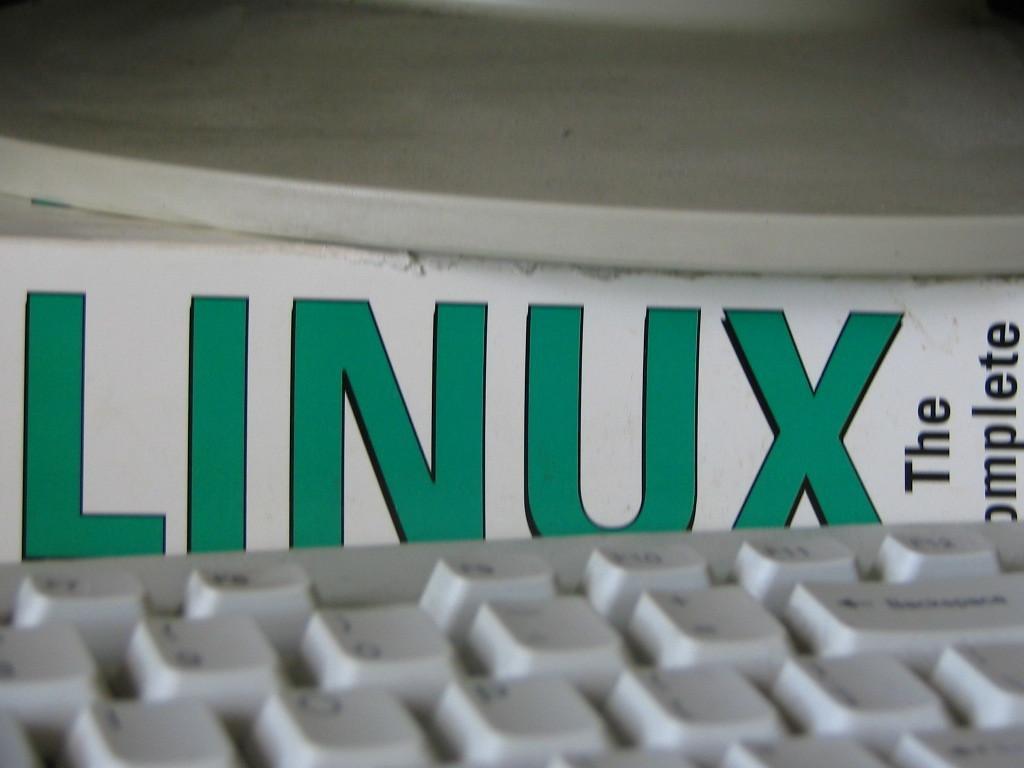In one or two sentences, can you explain what this image depicts? In this image we can see one white keyboard at the bottom of the image, one white board with text, one white object looks like a table on the top of the image. 